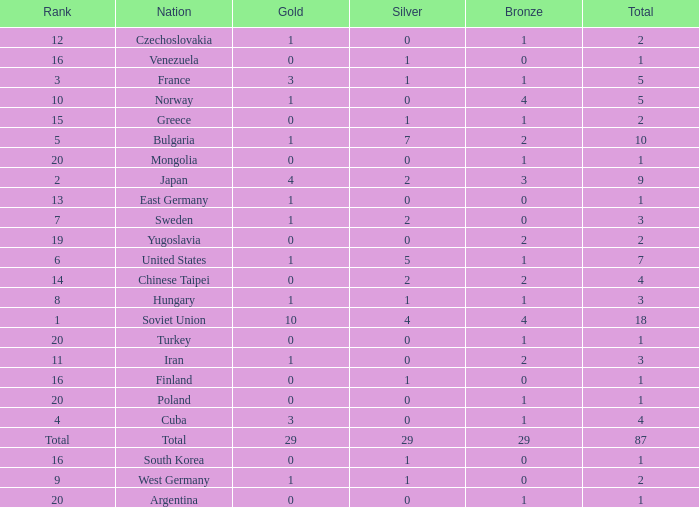Which rank has 1 silver medal and more than 1 gold medal? 3.0. 